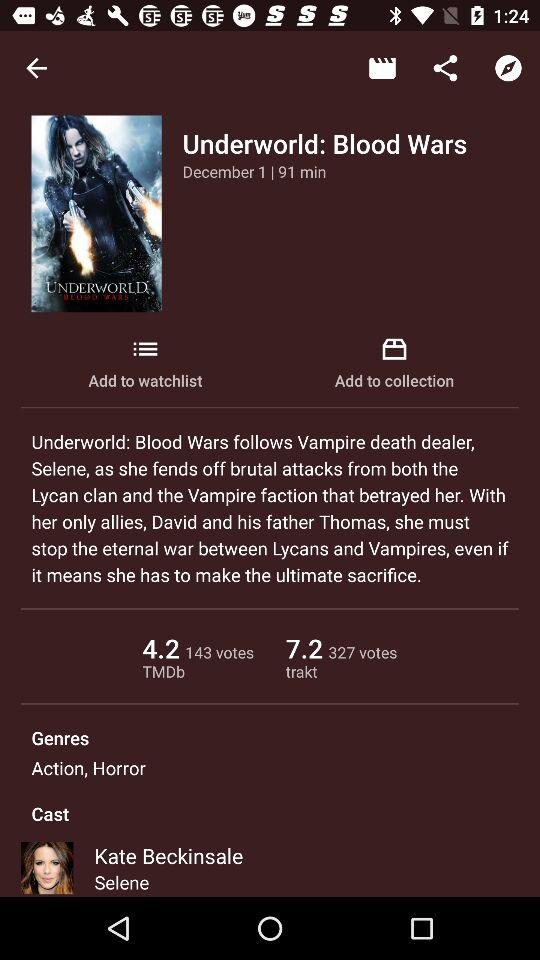When was the movie released? The movie was released on December 1. 